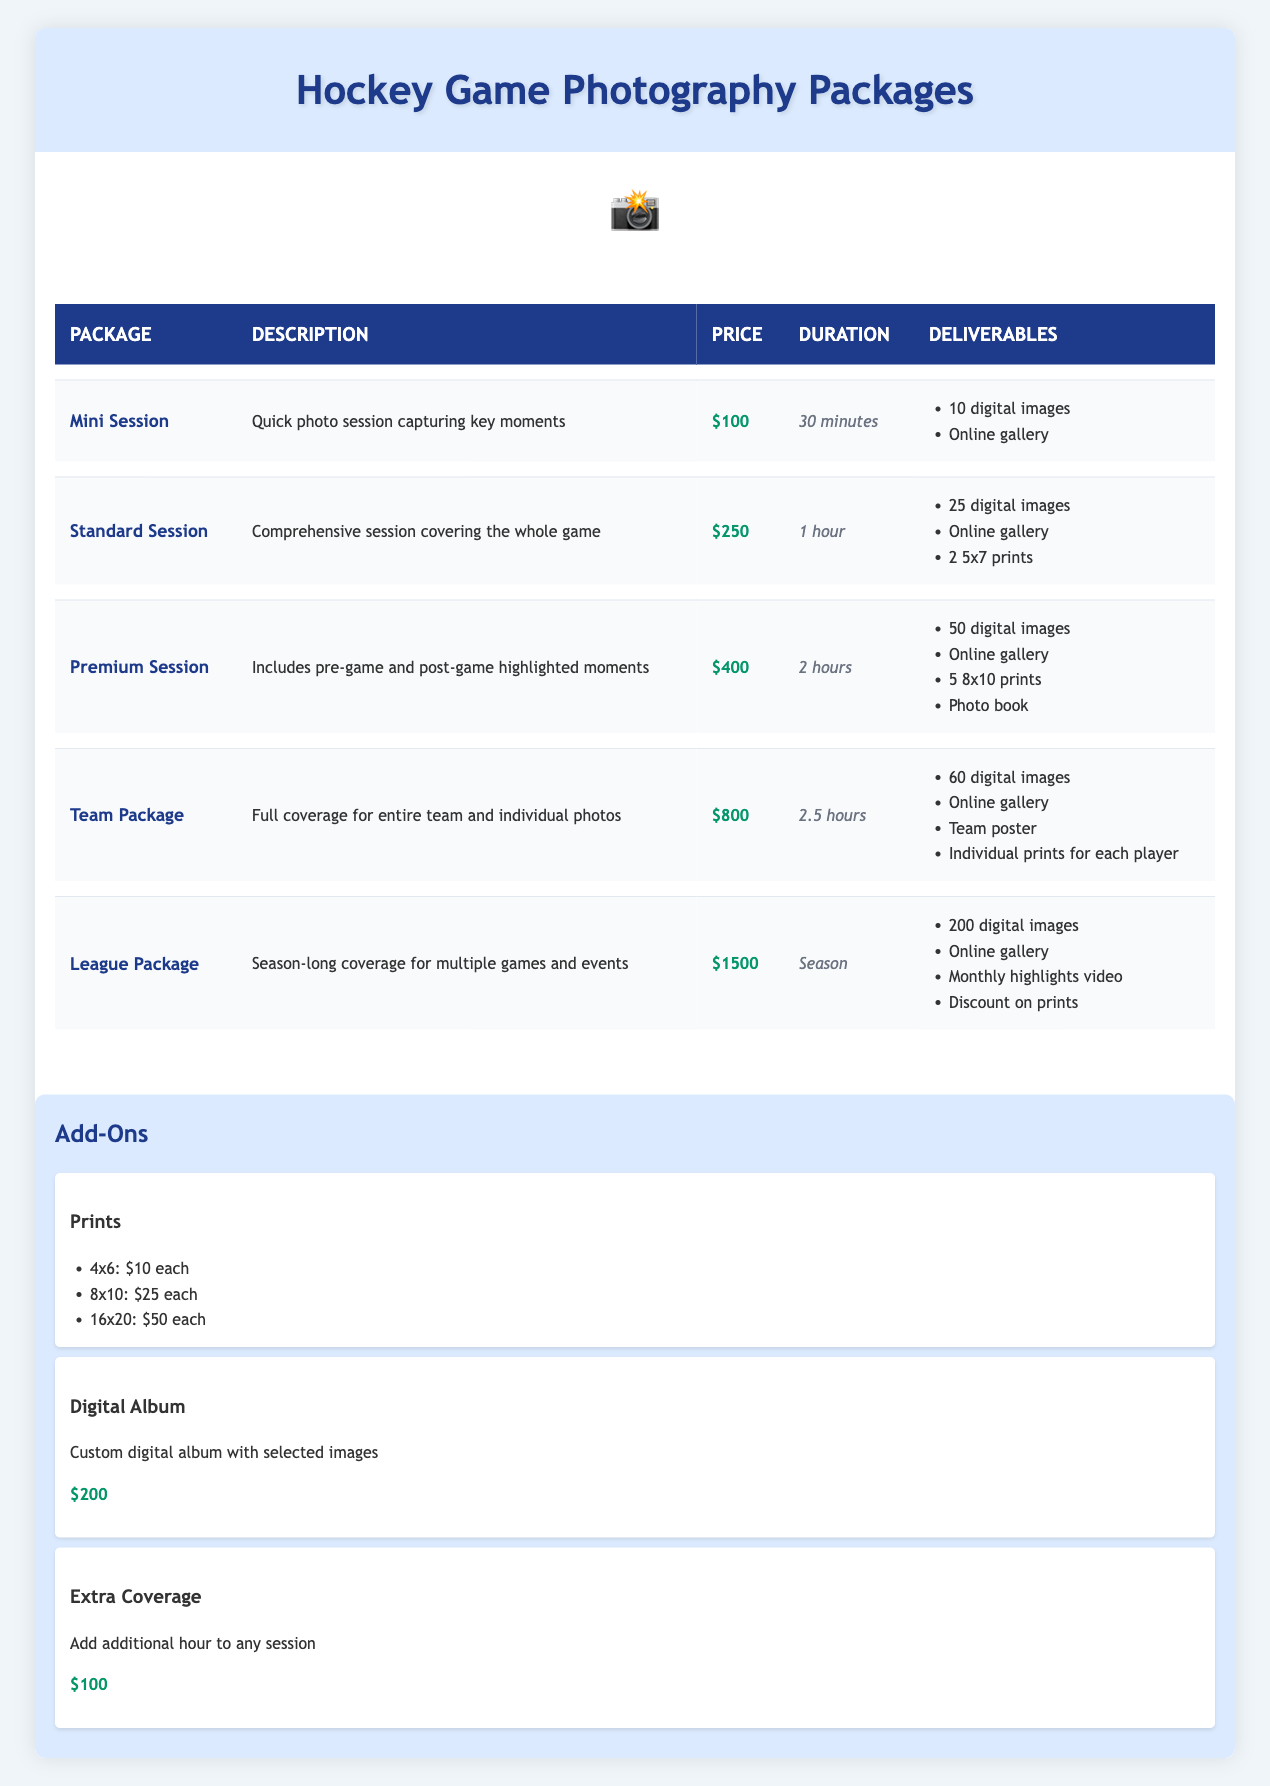What is the price of the Premium Session? The price for the Premium Session is directly listed in the table next to the package name.
Answer: $400 How many digital images are included in the Team Package? The Team Package description includes "60 digital images" in the deliverables section of the table.
Answer: 60 digital images Is the Standard Session longer than the Mini Session? The Standard Session duration is 1 hour while the Mini Session is 30 minutes, so 1 hour is longer than 30 minutes.
Answer: Yes What total number of digital images will I receive if I buy both the Mini Session and Standard Session? The Mini Session provides 10 digital images and the Standard Session provides 25 digital images. Adding them together: 10 + 25 = 35 digital images.
Answer: 35 digital images Does the League Package include a monthly highlights video? The League Package explicitly states that it includes a "Monthly highlights video" in its deliverables.
Answer: Yes What is the maximum number of digital images available in any package? The League Package has the highest number of digital images listed, with 200. I can compare this with other packages: Mini(10), Standard(25), Premium(50), Team(60), and find that 200 is indeed the highest.
Answer: 200 digital images If I need 2 hours of coverage, which sessions could I choose? I look for sessions that have a duration of 2 hours or more; the Premium Session offers 2 hours of coverage, while the Team Package lasts 2.5 hours. Both options fit the requirement.
Answer: Premium Session, Team Package How much does it cost to add an extra hour of coverage to any session? The Extra Coverage add-on directly lists the price, which is $100.
Answer: $100 What is the total cost if I book a Standard Session and add a Digital Album? The Standard Session is priced at $250 and the Digital Album is $200. To find the total cost, I add the two together: 250 + 200 = 450.
Answer: $450 